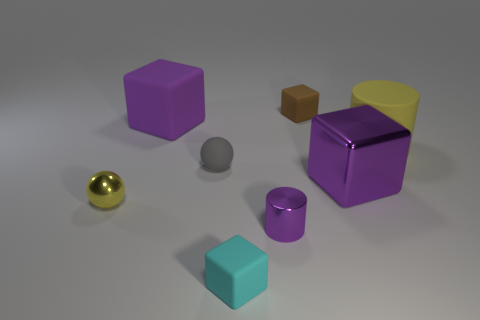How many other objects are there of the same shape as the big purple shiny thing?
Offer a very short reply. 3. What is the shape of the yellow object that is to the right of the big matte object that is to the left of the tiny block behind the cyan matte block?
Your answer should be very brief. Cylinder. How many spheres are large green metal objects or small gray rubber objects?
Offer a terse response. 1. Are there any cyan things in front of the big rubber object that is on the right side of the brown matte block?
Keep it short and to the point. Yes. There is a small brown rubber object; is its shape the same as the rubber thing in front of the yellow shiny ball?
Offer a terse response. Yes. What number of other objects are the same size as the rubber cylinder?
Offer a very short reply. 2. What number of green objects are large rubber cylinders or balls?
Make the answer very short. 0. How many blocks are behind the metallic cube and to the right of the big rubber block?
Make the answer very short. 1. What material is the block that is in front of the small shiny thing to the left of the purple object in front of the large shiny block?
Make the answer very short. Rubber. How many small yellow balls are the same material as the small purple cylinder?
Provide a succinct answer. 1. 